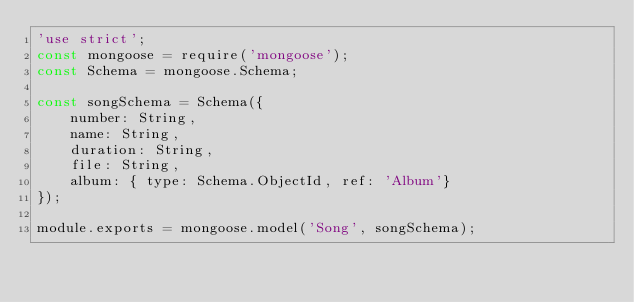Convert code to text. <code><loc_0><loc_0><loc_500><loc_500><_JavaScript_>'use strict';
const mongoose = require('mongoose');
const Schema = mongoose.Schema;

const songSchema = Schema({
    number: String,
    name: String,
    duration: String,
    file: String,
    album: { type: Schema.ObjectId, ref: 'Album'}
});

module.exports = mongoose.model('Song', songSchema);</code> 